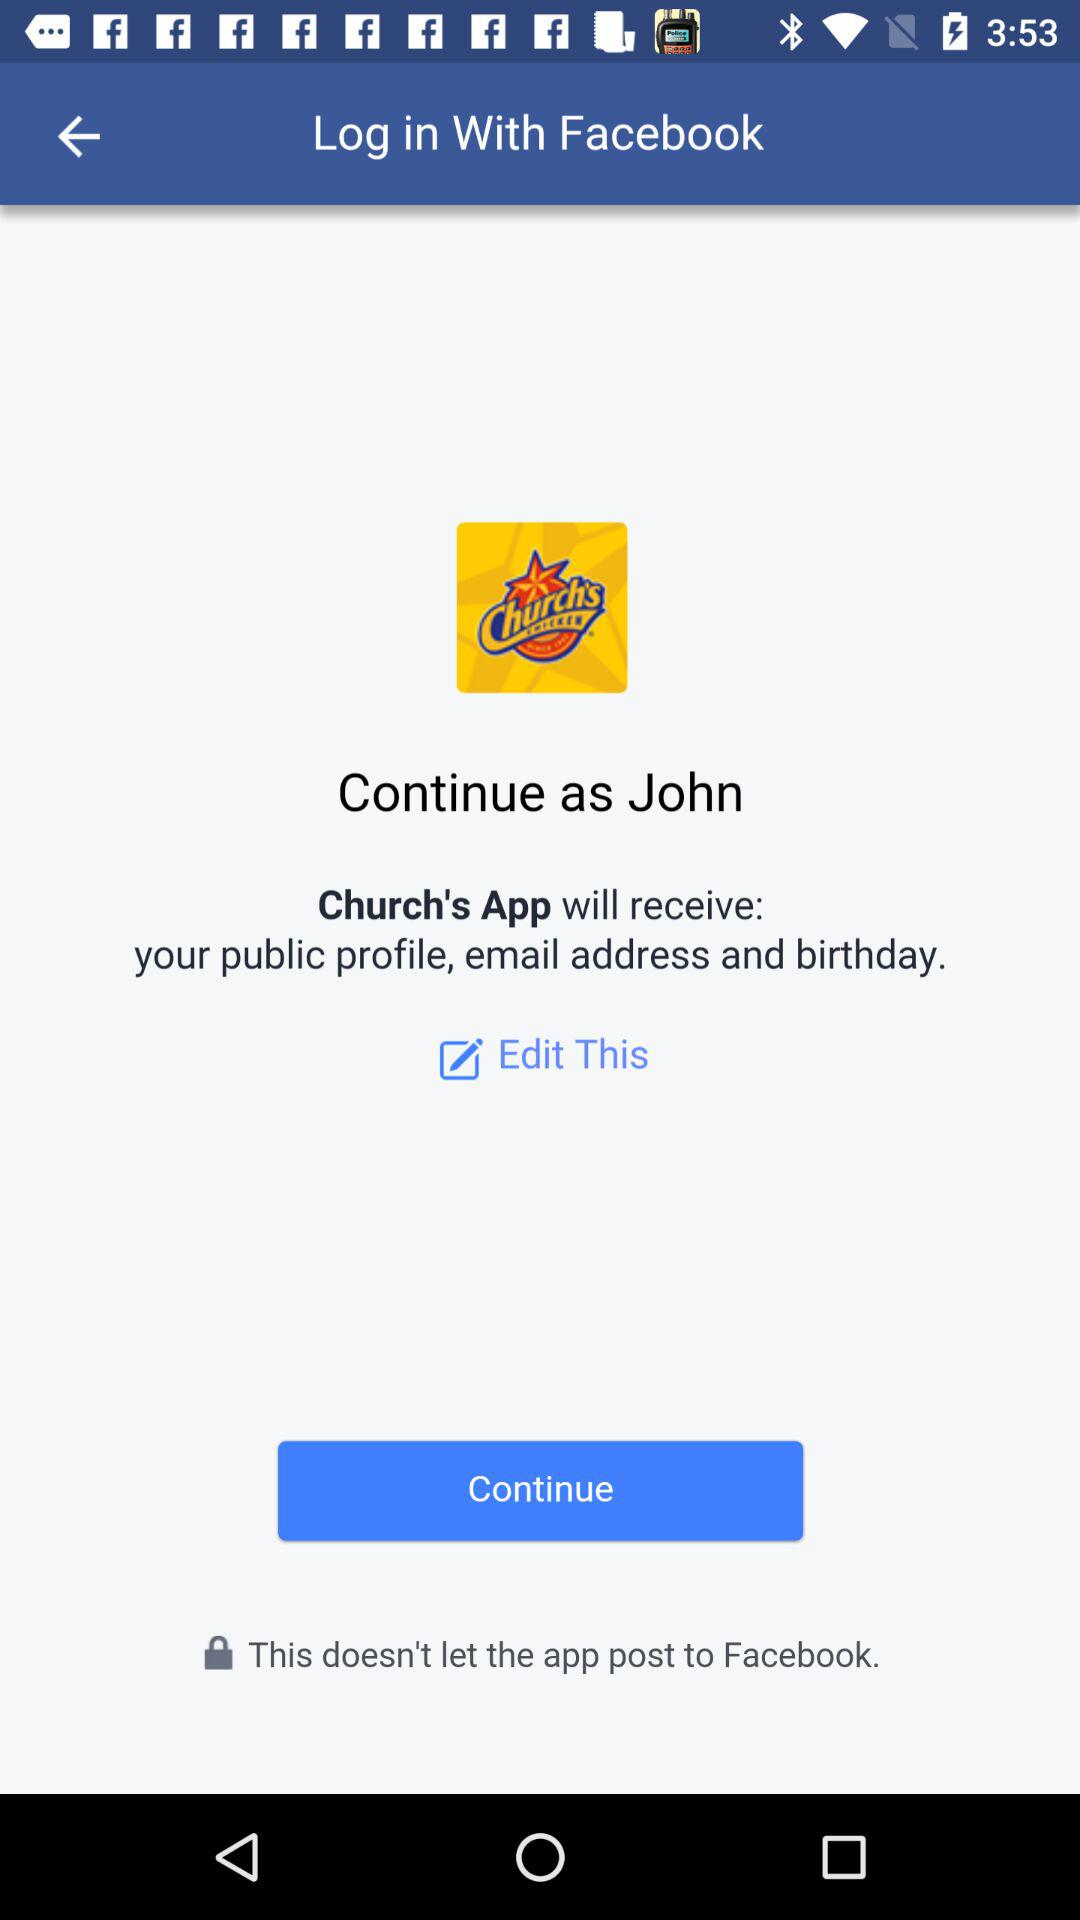What is the user name? The user name is John. 